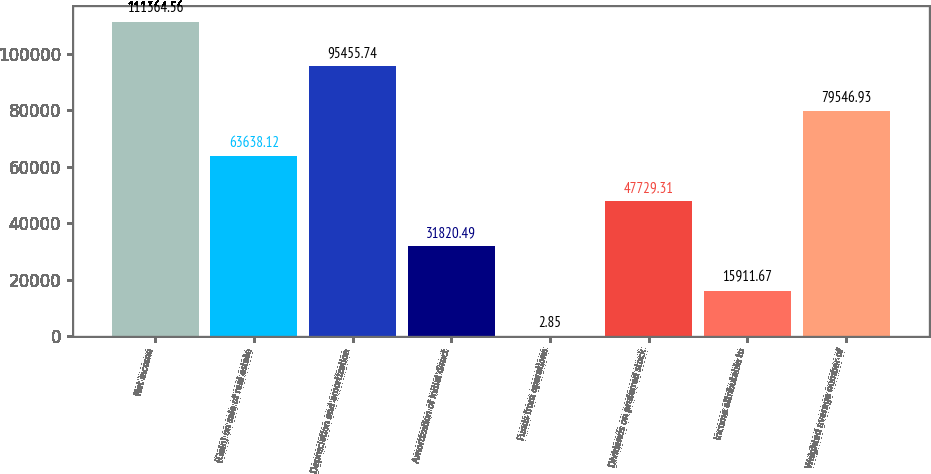Convert chart. <chart><loc_0><loc_0><loc_500><loc_500><bar_chart><fcel>Net income<fcel>(Gain) on sale of real estate<fcel>Depreciation and amortization<fcel>Amortization of initial direct<fcel>Funds from operations<fcel>Dividends on preferred stock<fcel>Income attributable to<fcel>Weighted average number of<nl><fcel>111365<fcel>63638.1<fcel>95455.7<fcel>31820.5<fcel>2.85<fcel>47729.3<fcel>15911.7<fcel>79546.9<nl></chart> 